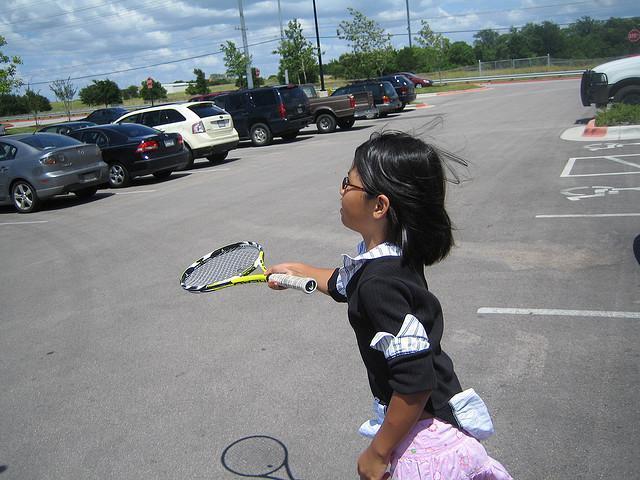How many vehicles are in the parking lot?
Give a very brief answer. 8. How many handicap parking spaces are visible?
Give a very brief answer. 2. How many cars are in the picture?
Give a very brief answer. 4. How many forks are on the table?
Give a very brief answer. 0. 